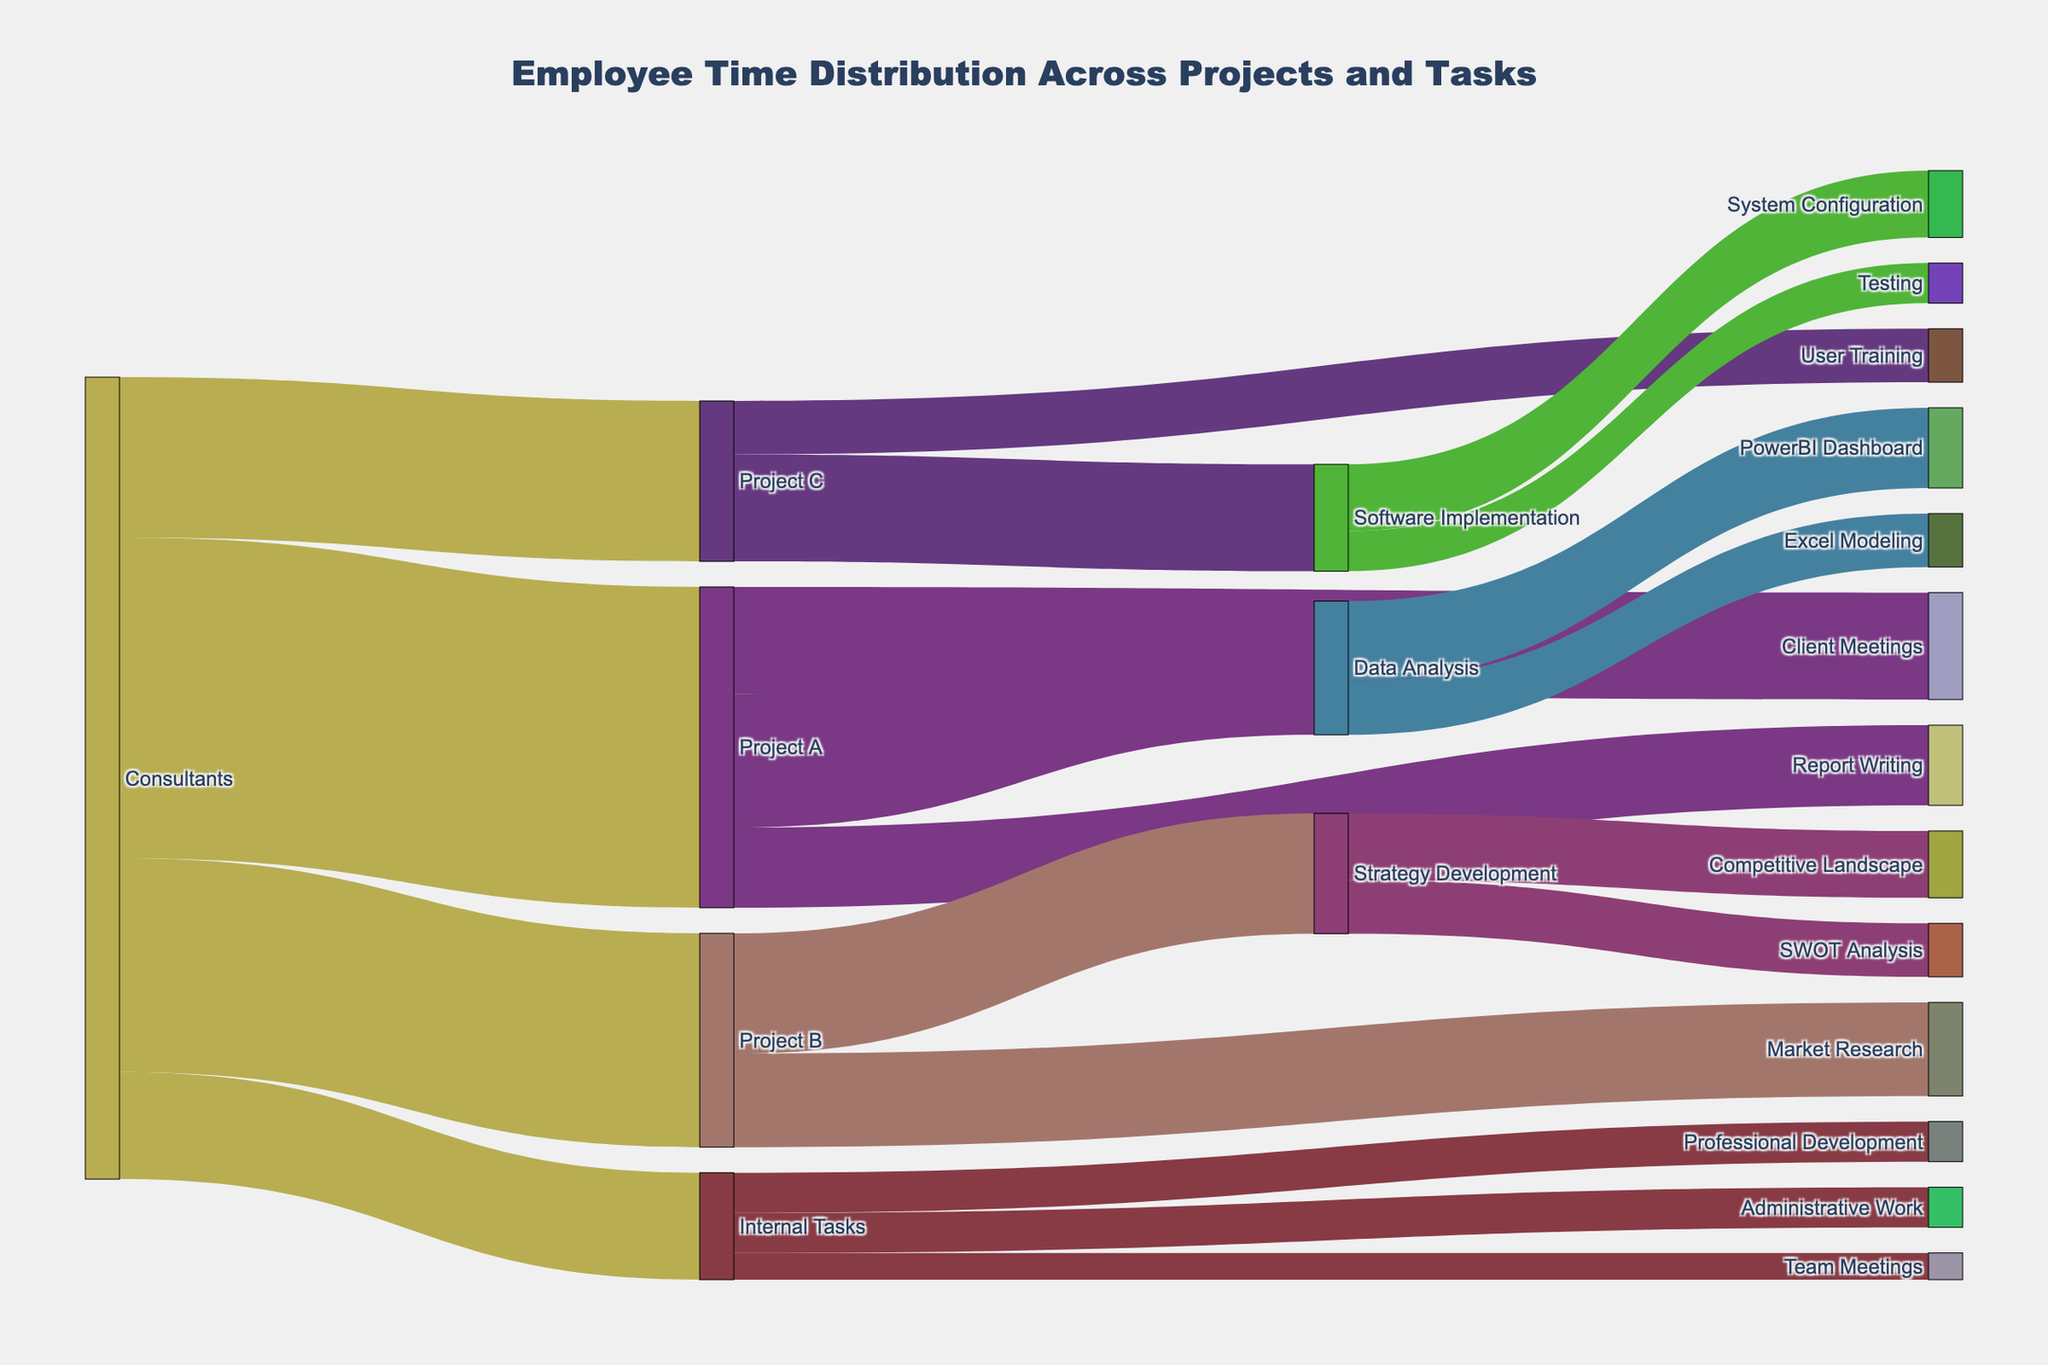Which project had the most hours allocated to it? From the figure, we look at the branches originating from "Consultants" to identify the time distribution across projects. Project A has the highest allocation with a value of 1200 hours.
Answer: Project A Which task under "Project A" has the least hours assigned to it? For Project A, the branches lead to "Client Meetings", "Data Analysis", and "Report Writing". "Report Writing" has 300 hours, which is the smallest among the three tasks.
Answer: Report Writing How much total time is spent on "Internal Tasks"? The time spent on "Internal Tasks" is the sum of hours for "Administrative Work", "Professional Development", and "Team Meetings": 150 + 150 + 100.
Answer: 400 Which internal task takes more time, "Administrative Work" or "Team Meetings"? From the figure, "Administrative Work" takes 150 hours and "Team Meetings" take 100 hours. Therefore, "Administrative Work" takes more time.
Answer: Administrative Work Compare the total time spent on "Market Research" and "Strategy Development" under "Project B". Which one is higher and by how much? For "Project B", "Market Research" is 350 hours and "Strategy Development" is 450 hours. The difference is 450 - 350 = 100.
Answer: Strategy Development by 100 What is the combined time spent on "Testing" and "User Training"? Under "Project C", "User Training" is 200 hours and "Testing" under "Software Implementation" is 150 hours. The total combined time is 200 + 150 = 350 hours.
Answer: 350 Which has higher hours, "Excel Modeling" or "SWOT Analysis"? "Excel Modeling" under "Data Analysis" is 200 hours, and "SWOT Analysis" under "Strategy Development" is also 200 hours. They both have equal hours.
Answer: Equal How many hours in total are dedicated to "Data Analysis" tasks under "Project A"? Under "Project A", tasks for "Data Analysis" are "PowerBI Dashboard" with 300 hours and "Excel Modeling" with 200 hours. The total is 300 + 200 = 500 hours.
Answer: 500 What’s the difference in hours between "Professional Development" and "System Configuration"? "Professional Development" is 150 hours, while "System Configuration" under "Software Implementation" is 250 hours. The difference is 250 - 150 = 100.
Answer: 100 Based on the Sankey diagram, is more time spent on "Client Meetings" or "Competitive Landscape"? "Client Meetings" under "Project A" is 400 hours, whereas "Competitive Landscape" under "Strategy Development" is 250 hours. Therefore, more time is spent on "Client Meetings".
Answer: Client Meetings 